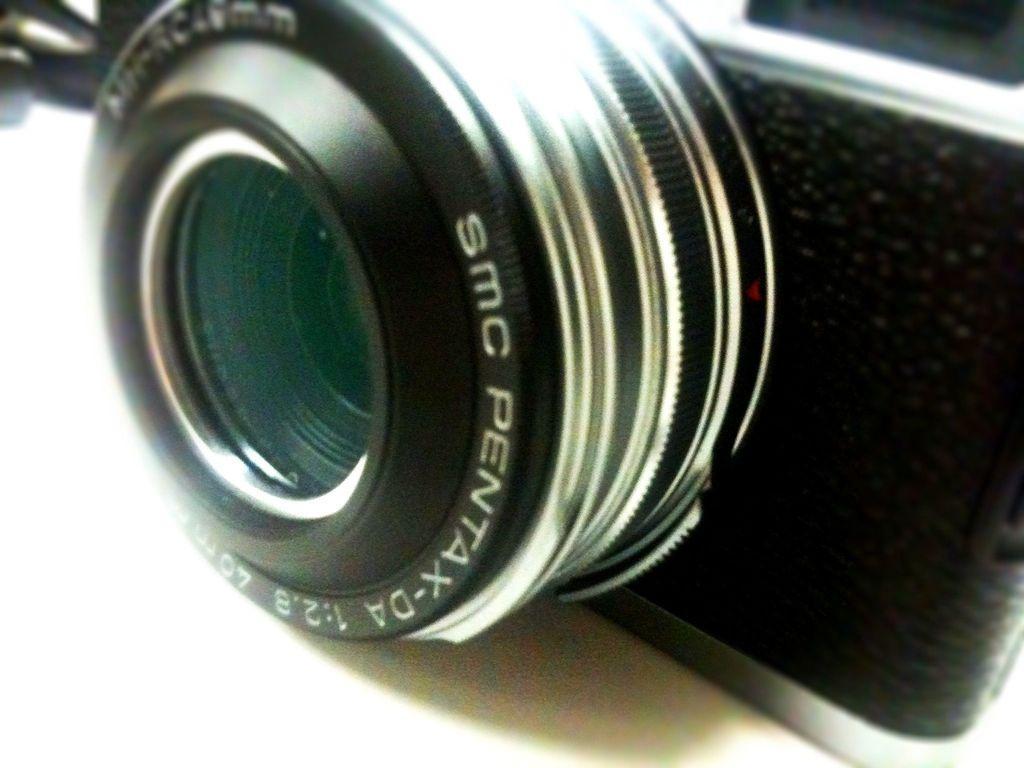Can you describe this image briefly? In this picture we can see a camera placed on a platform. 